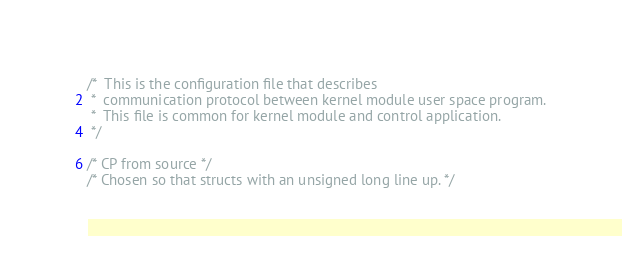<code> <loc_0><loc_0><loc_500><loc_500><_C_>/*  This is the configuration file that describes
 *  communication protocol between kernel module user space program.
 *  This file is common for kernel module and control application.
 */

/* CP from source */
/* Chosen so that structs with an unsigned long line up. */</code> 